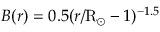Convert formula to latex. <formula><loc_0><loc_0><loc_500><loc_500>B ( r ) = 0 . 5 ( r / R _ { \odot } - 1 ) ^ { - 1 . 5 }</formula> 